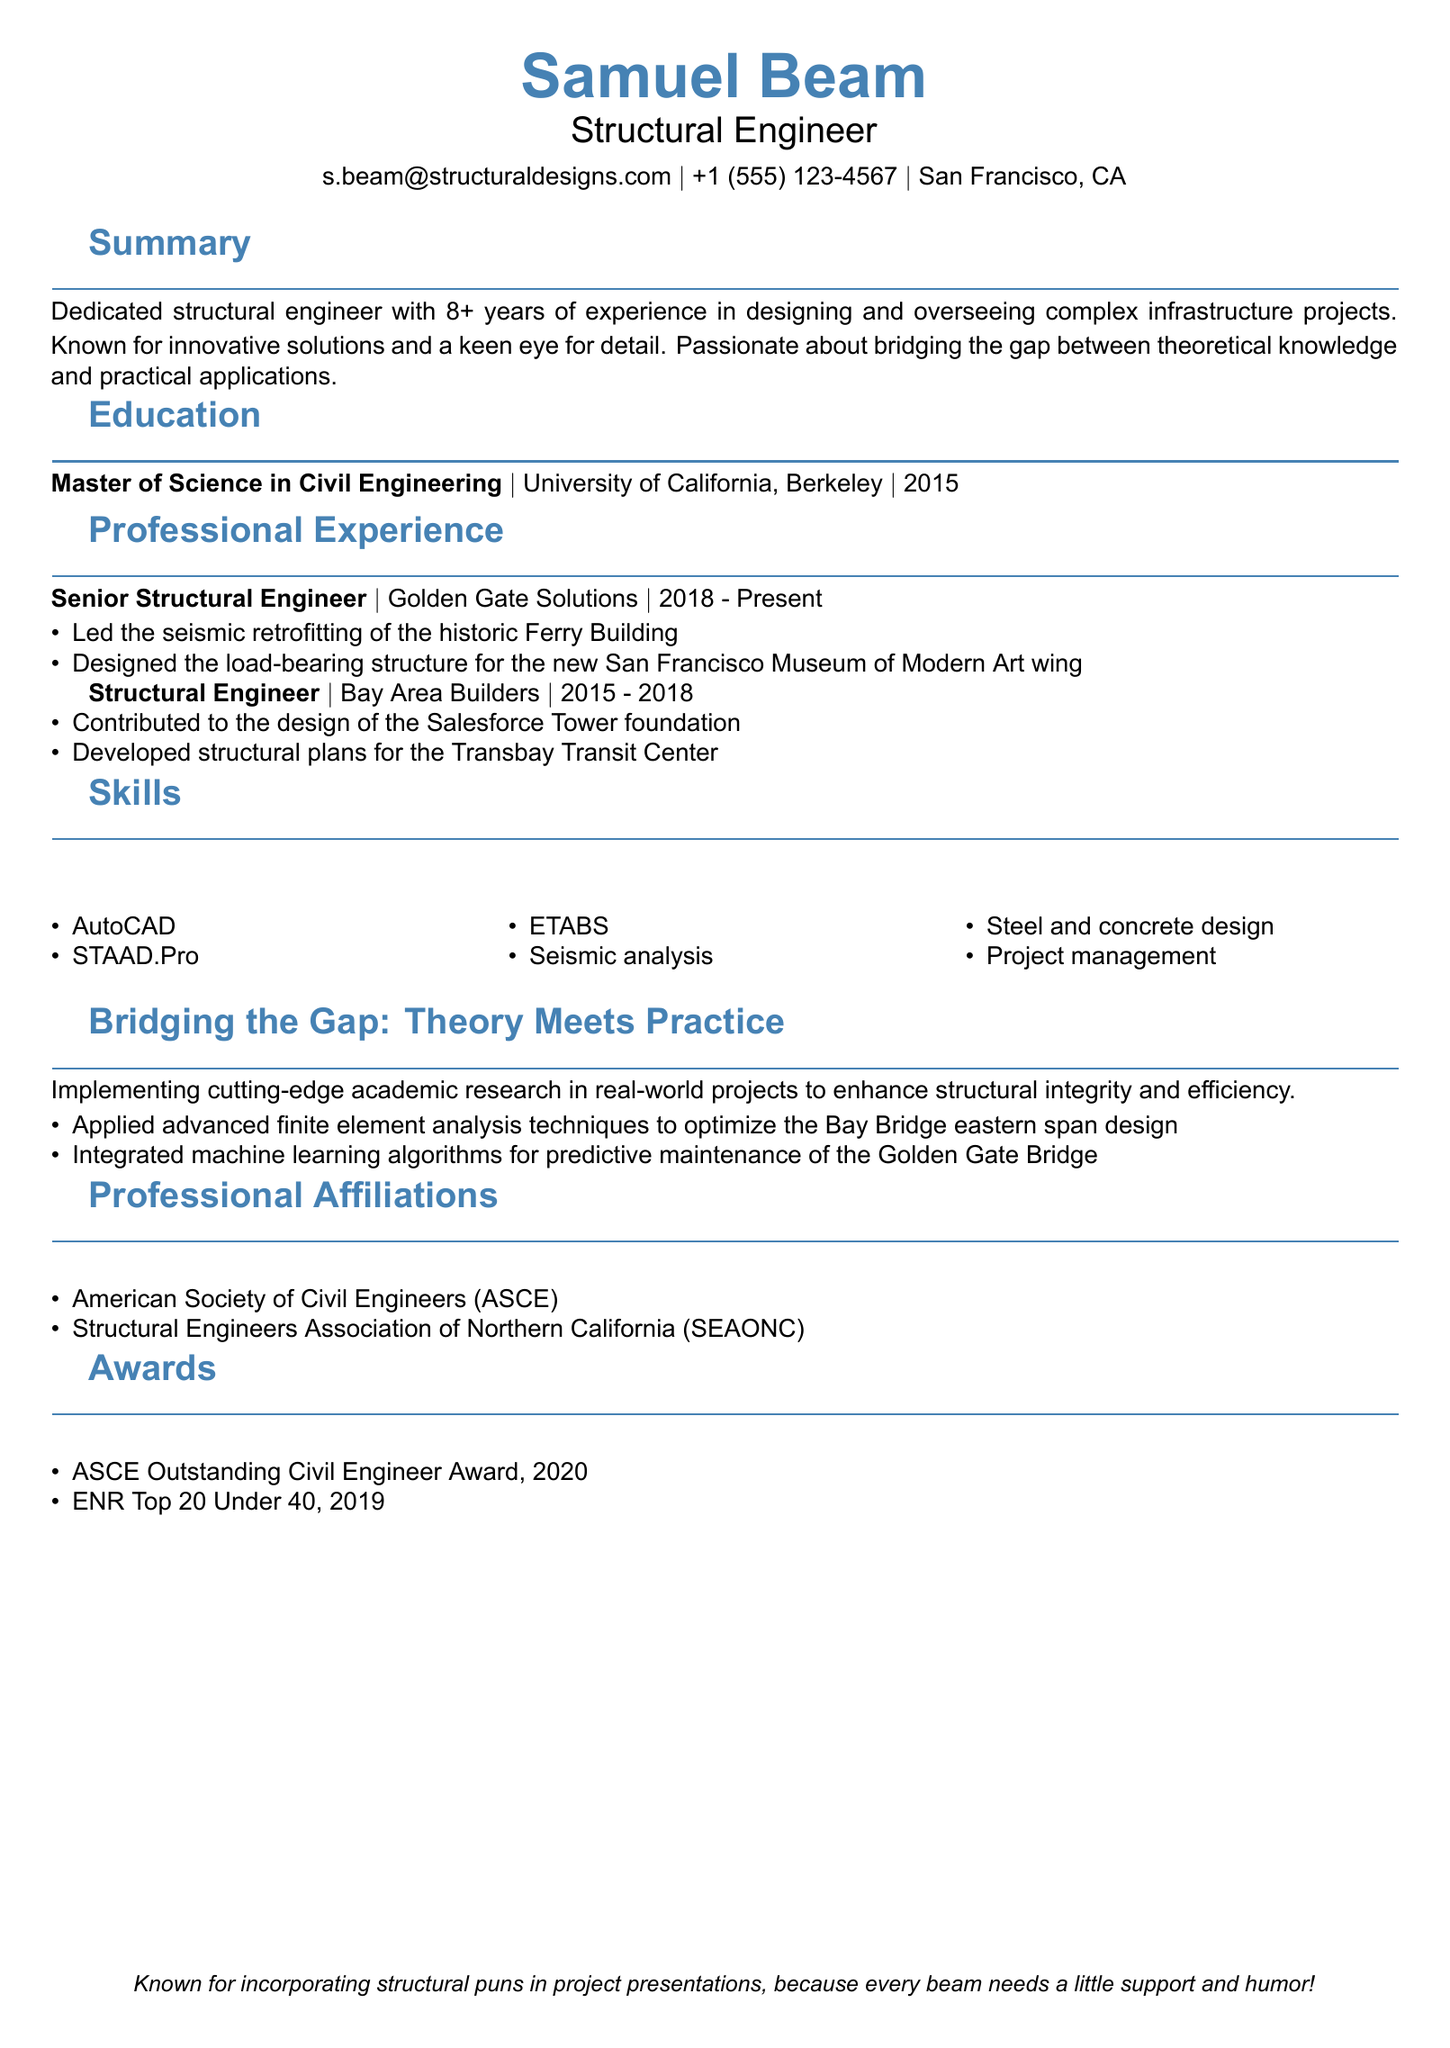What is Samuel Beam's job title? The job title is listed under personal info in the document.
Answer: Structural Engineer How many years of experience does Samuel Beam have? The summary section specifies the years of experience.
Answer: 8+ Which university did Samuel Beam attend for his Master's degree? The education section provides the name of the institution where he earned his degree.
Answer: University of California, Berkeley What major project was completed at Golden Gate Solutions? The professional experience section includes this information about project work.
Answer: Seismic retrofitting of the historic Ferry Building What innovative technique was applied to the Bay Bridge design? The "Bridging the Gap" section describes specific methodologies used in projects.
Answer: Finite element analysis Name one professional affiliation of Samuel Beam. The professional affiliations section lists the organizations he is a member of.
Answer: ASCE What award did Samuel Beam receive in 2020? The awards section highlights his accomplishments.
Answer: ASCE Outstanding Civil Engineer Award In which year did Samuel Beam earn his Master's degree? The education section states the year of completion for his degree.
Answer: 2015 What is a unique aspect of Samuel Beam's presentation style? The personal touch section describes a notable characteristic of his presentations.
Answer: Structural puns 